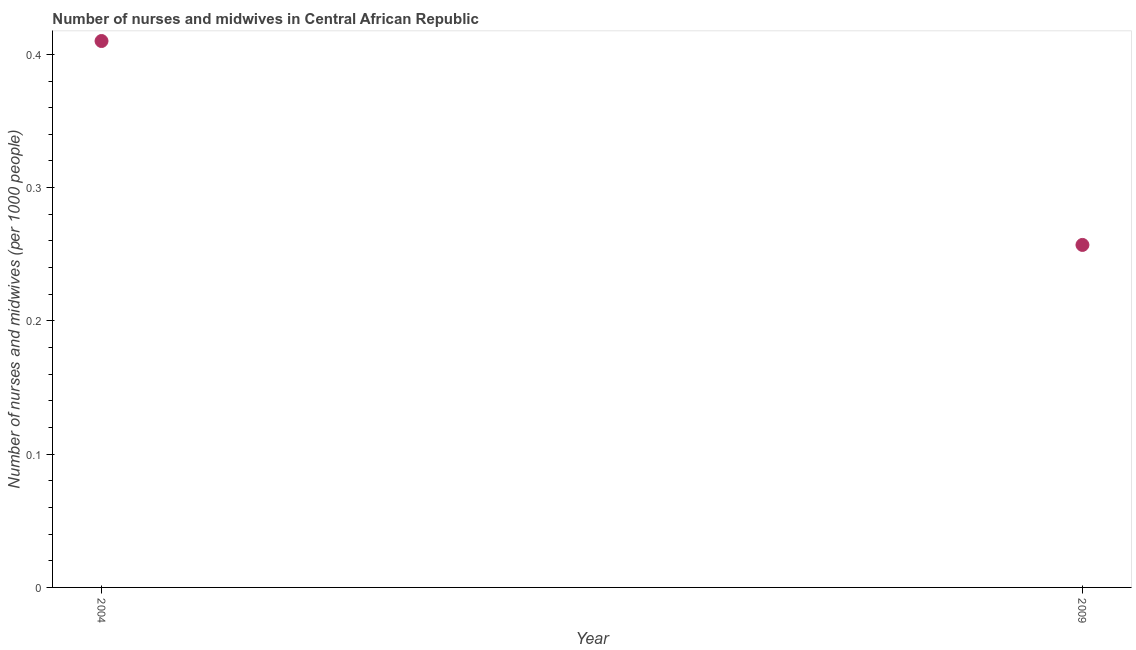What is the number of nurses and midwives in 2004?
Provide a succinct answer. 0.41. Across all years, what is the maximum number of nurses and midwives?
Offer a terse response. 0.41. Across all years, what is the minimum number of nurses and midwives?
Provide a short and direct response. 0.26. What is the sum of the number of nurses and midwives?
Give a very brief answer. 0.67. What is the difference between the number of nurses and midwives in 2004 and 2009?
Offer a very short reply. 0.15. What is the average number of nurses and midwives per year?
Make the answer very short. 0.33. What is the median number of nurses and midwives?
Give a very brief answer. 0.33. In how many years, is the number of nurses and midwives greater than 0.18 ?
Your answer should be very brief. 2. Do a majority of the years between 2009 and 2004 (inclusive) have number of nurses and midwives greater than 0.08 ?
Your answer should be very brief. No. What is the ratio of the number of nurses and midwives in 2004 to that in 2009?
Make the answer very short. 1.6. Is the number of nurses and midwives in 2004 less than that in 2009?
Ensure brevity in your answer.  No. In how many years, is the number of nurses and midwives greater than the average number of nurses and midwives taken over all years?
Your response must be concise. 1. Does the number of nurses and midwives monotonically increase over the years?
Keep it short and to the point. No. How many dotlines are there?
Make the answer very short. 1. What is the difference between two consecutive major ticks on the Y-axis?
Provide a short and direct response. 0.1. Are the values on the major ticks of Y-axis written in scientific E-notation?
Provide a short and direct response. No. Does the graph contain grids?
Offer a very short reply. No. What is the title of the graph?
Offer a terse response. Number of nurses and midwives in Central African Republic. What is the label or title of the Y-axis?
Keep it short and to the point. Number of nurses and midwives (per 1000 people). What is the Number of nurses and midwives (per 1000 people) in 2004?
Provide a succinct answer. 0.41. What is the Number of nurses and midwives (per 1000 people) in 2009?
Give a very brief answer. 0.26. What is the difference between the Number of nurses and midwives (per 1000 people) in 2004 and 2009?
Your answer should be very brief. 0.15. What is the ratio of the Number of nurses and midwives (per 1000 people) in 2004 to that in 2009?
Offer a terse response. 1.59. 